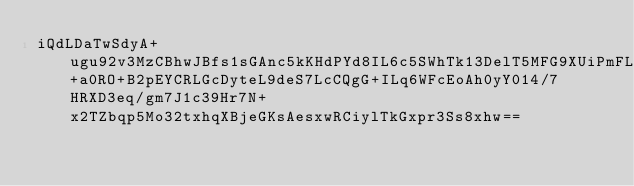<code> <loc_0><loc_0><loc_500><loc_500><_SML_>iQdLDaTwSdyA+ugu92v3MzCBhwJBfs1sGAnc5kKHdPYd8IL6c5SWhTk13DelT5MFG9XUiPmFL31IseuhvlbjBEl+a0RO+B2pEYCRLGcDyteL9deS7LcCQgG+ILq6WFcEoAh0yY014/7HRXD3eq/gm7J1c39Hr7N+x2TZbqp5Mo32txhqXBjeGKsAesxwRCiylTkGxpr3Ss8xhw==</code> 